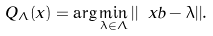Convert formula to latex. <formula><loc_0><loc_0><loc_500><loc_500>Q _ { \Lambda } ( x ) = \arg \min _ { \lambda \in \Lambda } { | | \ x b - \lambda | | } .</formula> 